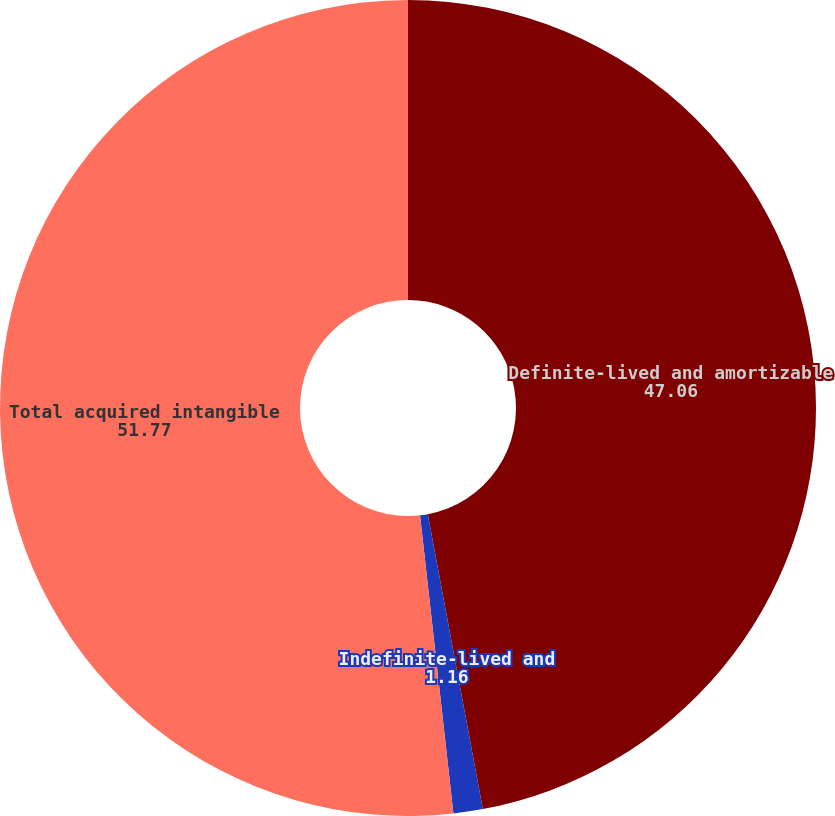<chart> <loc_0><loc_0><loc_500><loc_500><pie_chart><fcel>Definite-lived and amortizable<fcel>Indefinite-lived and<fcel>Total acquired intangible<nl><fcel>47.06%<fcel>1.16%<fcel>51.77%<nl></chart> 